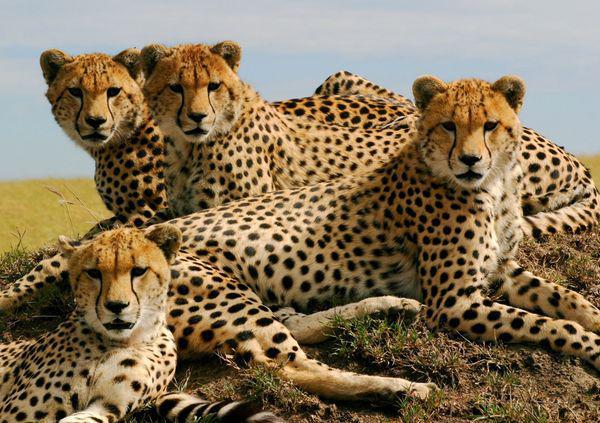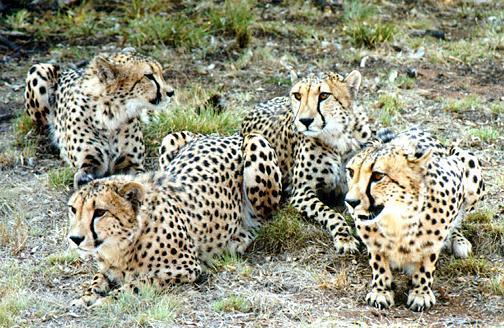The first image is the image on the left, the second image is the image on the right. Given the left and right images, does the statement "Each image shows a single spotted wild cat, and each cat is in a similar type of pose." hold true? Answer yes or no. No. The first image is the image on the left, the second image is the image on the right. Evaluate the accuracy of this statement regarding the images: "At least one of the animals is sitting on the ground.". Is it true? Answer yes or no. Yes. 